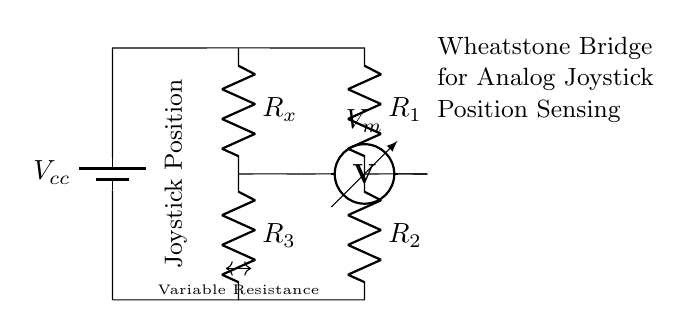What type of circuit is shown? This diagram represents a Wheatstone bridge circuit, which is often used to measure unknown resistances. It consists of four resistors arranged in a diamond shape, where two of the resistors are fixed and one is variable.
Answer: Wheatstone bridge What is the role of R_x in the circuit? R_x is the variable resistor that can change its value based on the joystick's position, allowing it to affect the balance of the bridge and thus the output voltage measured.
Answer: Variable resistance What does V_m represent? V_m indicates the voltage measurement across the bridge, showing the potential difference when the bridge is balanced or unbalanced, which corresponds to the joystick's position.
Answer: Voltage measurement How many resistors are there in total? There are five resistors in total (R_1, R_2, R_x, R_3, and the variable resistance connected to the position). This includes two fixed and one variable resistor in the bottom path.
Answer: Five What is indicated by the term "Joystick Position"? The term relates to how the joystick's position alters the variable resistance R_x, which affects the balance in the Wheatstone bridge and consequently the output voltage V_m.
Answer: Analog joystick control How can this circuit measure precise positions? The Wheatstone bridge measures resistance changes as the joystick moves, producing a proportional voltage output that reflects the joystick's position with high accuracy. This precise output allows for fine control in gaming applications.
Answer: Resistance measurement 